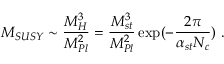<formula> <loc_0><loc_0><loc_500><loc_500>M _ { S U S Y } \sim { \frac { M _ { H } ^ { 3 } } { M _ { P l } ^ { 2 } } } = { \frac { M _ { s t } ^ { 3 } } { M _ { P l } ^ { 2 } } } \exp ( - { \frac { 2 \pi } { \alpha _ { s t } N _ { c } } } ) .</formula> 